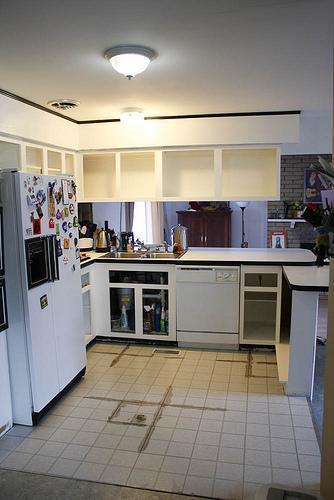How many people in the picture?
Give a very brief answer. 0. 